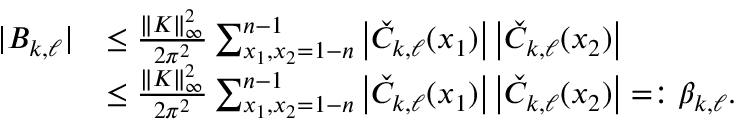Convert formula to latex. <formula><loc_0><loc_0><loc_500><loc_500>\begin{array} { r l } { | B _ { k , \ell } | } & { \leq \frac { \| K \| _ { \infty } ^ { 2 } } { 2 \pi ^ { 2 } } \sum _ { x _ { 1 } , x _ { 2 } = 1 - n } ^ { n - 1 } \left | \check { C } _ { k , \ell } ( x _ { 1 } ) \right | \left | \check { C } _ { k , \ell } ( x _ { 2 } ) \right | } \\ & { \leq \frac { \| K \| _ { \infty } ^ { 2 } } { 2 \pi ^ { 2 } } \sum _ { x _ { 1 } , x _ { 2 } = 1 - n } ^ { n - 1 } \left | \check { C } _ { k , \ell } ( x _ { 1 } ) \right | \left | \check { C } _ { k , \ell } ( x _ { 2 } ) \right | = \colon \beta _ { k , \ell } . } \end{array}</formula> 